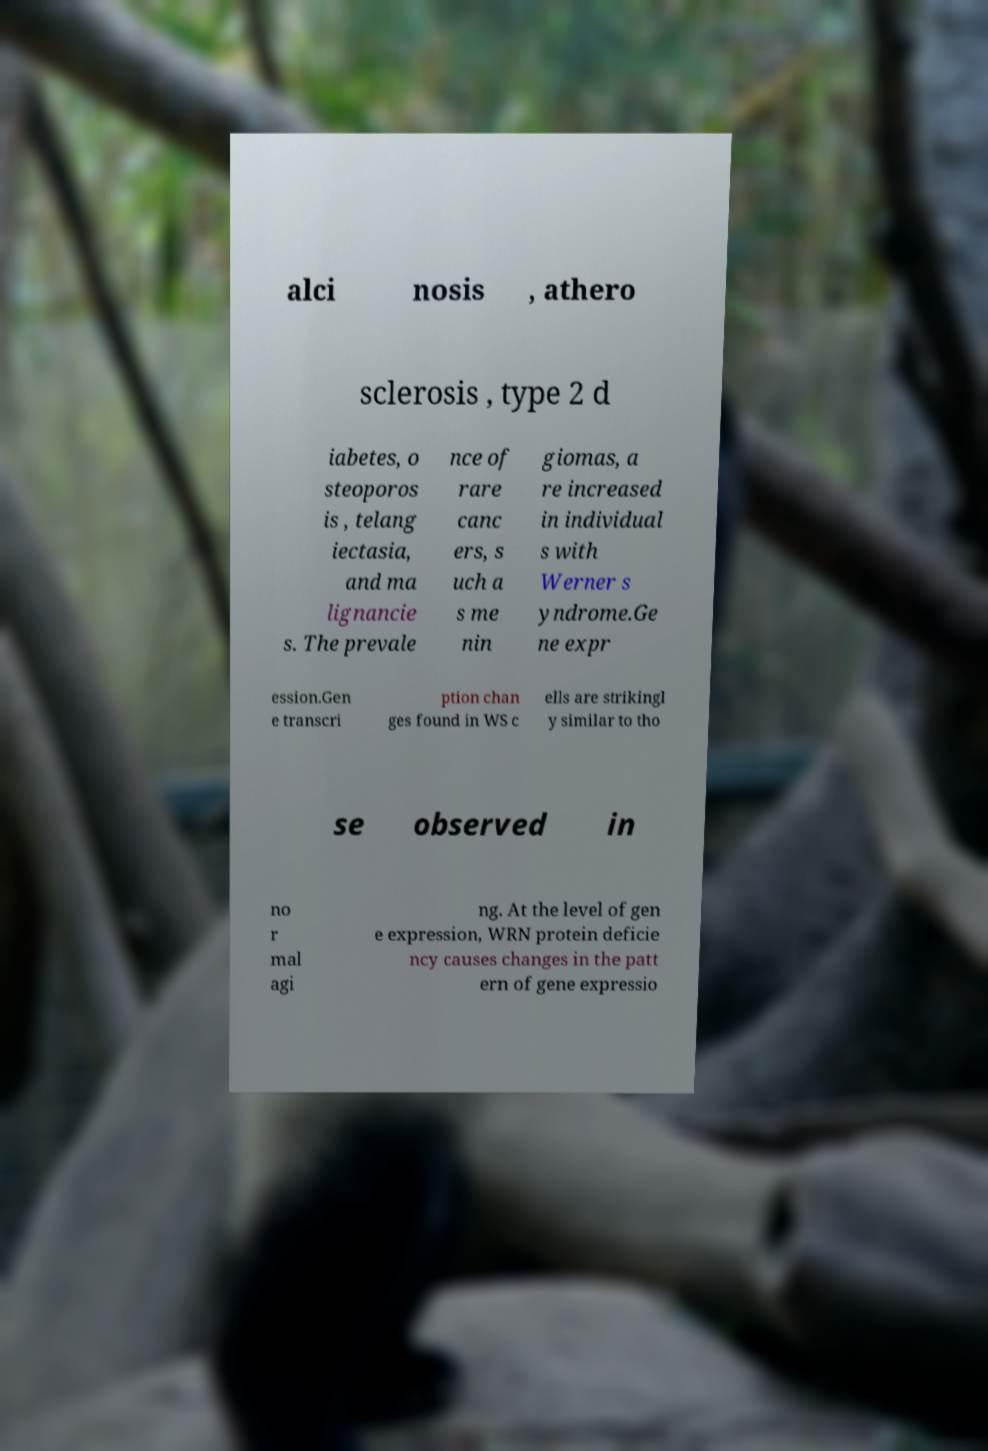I need the written content from this picture converted into text. Can you do that? alci nosis , athero sclerosis , type 2 d iabetes, o steoporos is , telang iectasia, and ma lignancie s. The prevale nce of rare canc ers, s uch a s me nin giomas, a re increased in individual s with Werner s yndrome.Ge ne expr ession.Gen e transcri ption chan ges found in WS c ells are strikingl y similar to tho se observed in no r mal agi ng. At the level of gen e expression, WRN protein deficie ncy causes changes in the patt ern of gene expressio 